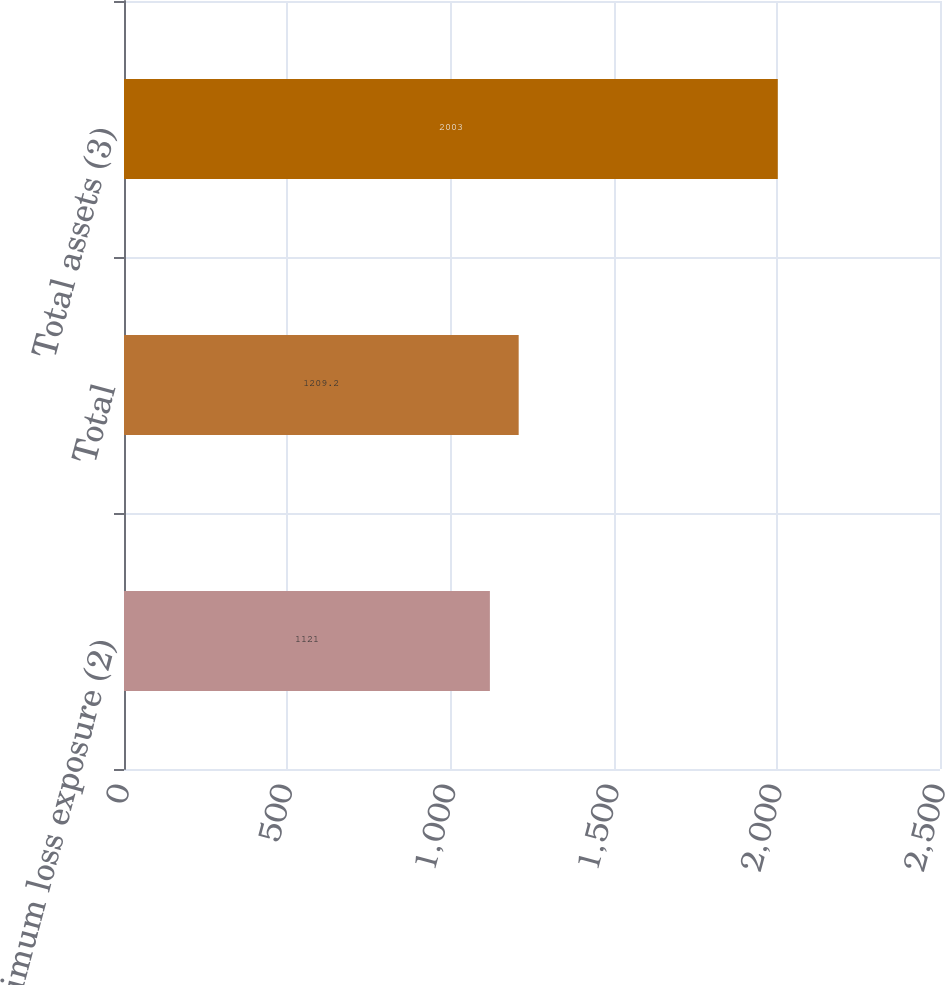<chart> <loc_0><loc_0><loc_500><loc_500><bar_chart><fcel>Maximum loss exposure (2)<fcel>Total<fcel>Total assets (3)<nl><fcel>1121<fcel>1209.2<fcel>2003<nl></chart> 